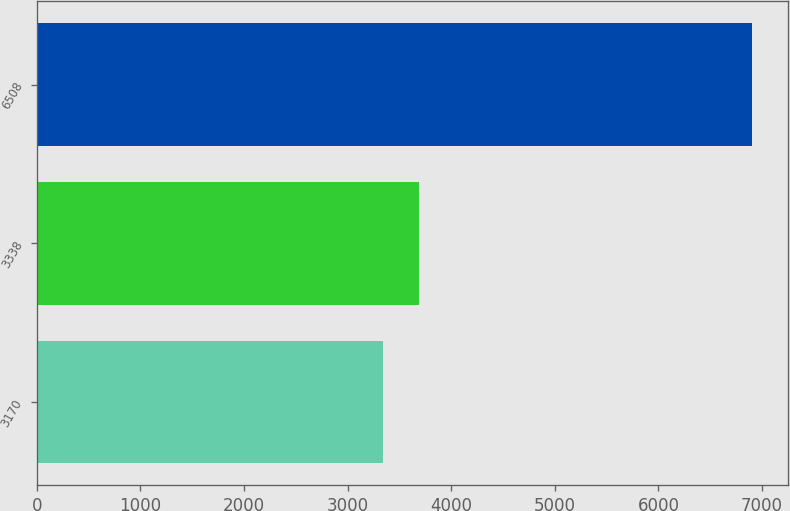Convert chart. <chart><loc_0><loc_0><loc_500><loc_500><bar_chart><fcel>3170<fcel>3338<fcel>6508<nl><fcel>3337<fcel>3693.9<fcel>6906<nl></chart> 